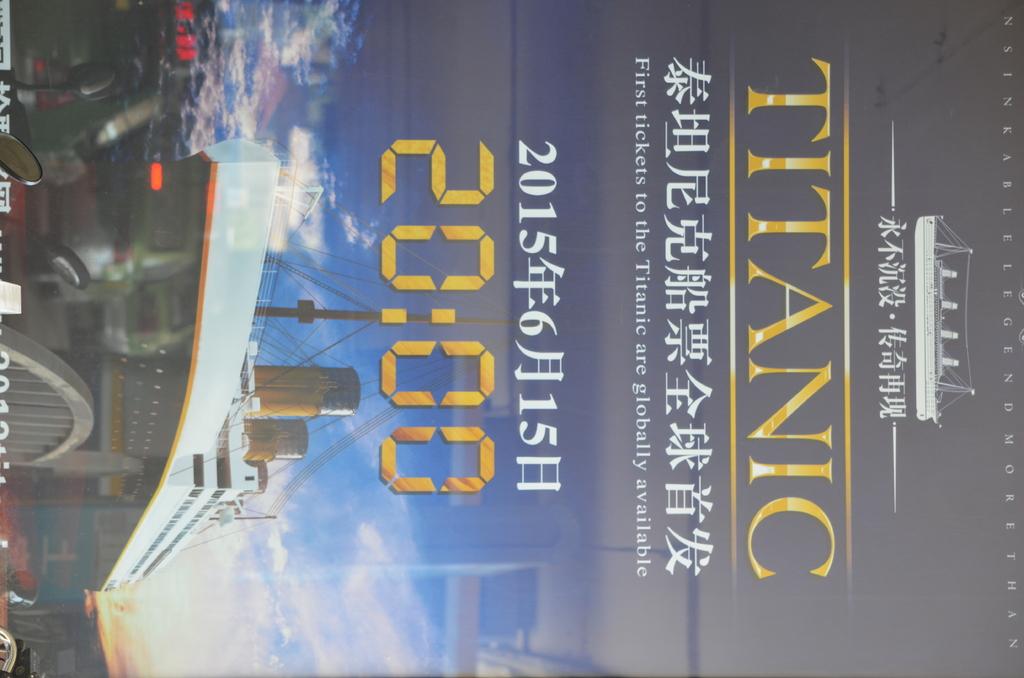What does the cover of the book have a picture of?
Ensure brevity in your answer.  Titanic. 